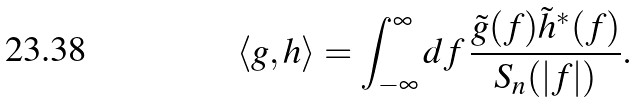Convert formula to latex. <formula><loc_0><loc_0><loc_500><loc_500>\langle g , h \rangle = \int _ { - \infty } ^ { \infty } d f \, \frac { \tilde { g } ( f ) \tilde { h } ^ { * } ( f ) } { S _ { n } ( | f | ) } .</formula> 